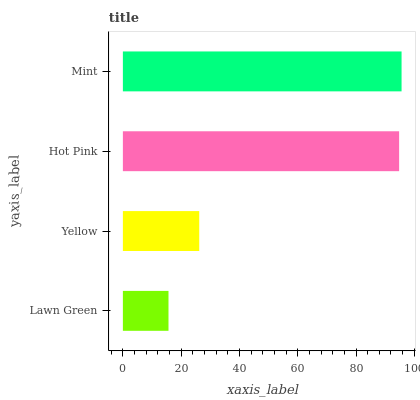Is Lawn Green the minimum?
Answer yes or no. Yes. Is Mint the maximum?
Answer yes or no. Yes. Is Yellow the minimum?
Answer yes or no. No. Is Yellow the maximum?
Answer yes or no. No. Is Yellow greater than Lawn Green?
Answer yes or no. Yes. Is Lawn Green less than Yellow?
Answer yes or no. Yes. Is Lawn Green greater than Yellow?
Answer yes or no. No. Is Yellow less than Lawn Green?
Answer yes or no. No. Is Hot Pink the high median?
Answer yes or no. Yes. Is Yellow the low median?
Answer yes or no. Yes. Is Lawn Green the high median?
Answer yes or no. No. Is Mint the low median?
Answer yes or no. No. 